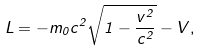Convert formula to latex. <formula><loc_0><loc_0><loc_500><loc_500>L = - m _ { 0 } c ^ { 2 } \sqrt { 1 - \frac { v ^ { 2 } } { c ^ { 2 } } } - V ,</formula> 